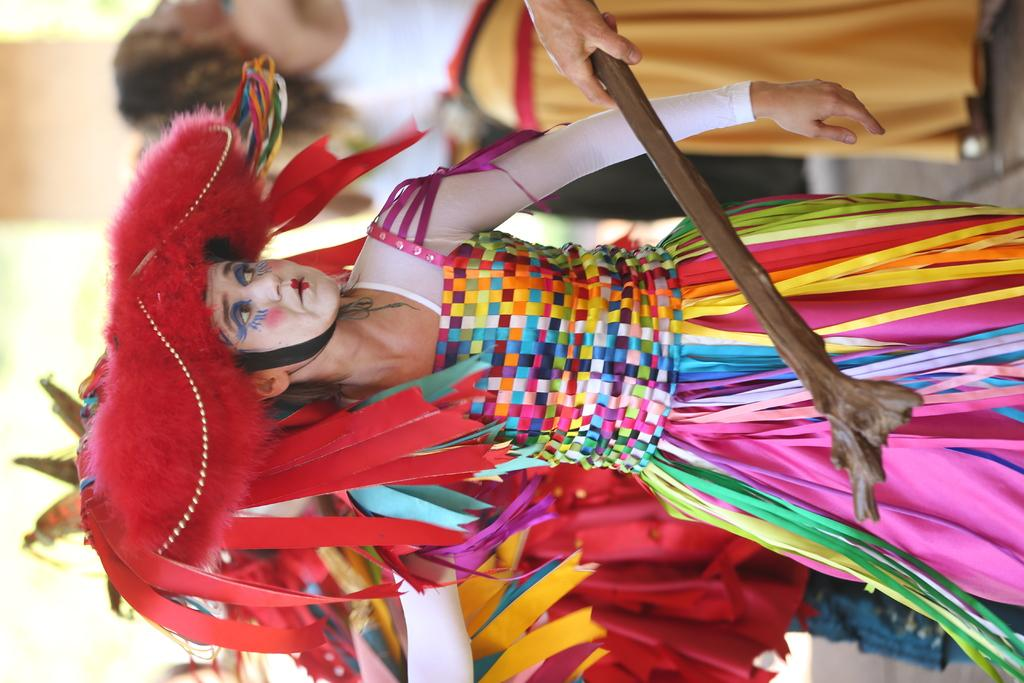What are the people in the image wearing? The people in the image are wearing costumes. Can you describe the object being held by a person's hand at the top of the image? A person's hand is holding a stick at the top of the image. What type of coach is present in the image? There is no coach present in the image; it features people wearing costumes and a person holding a stick. 